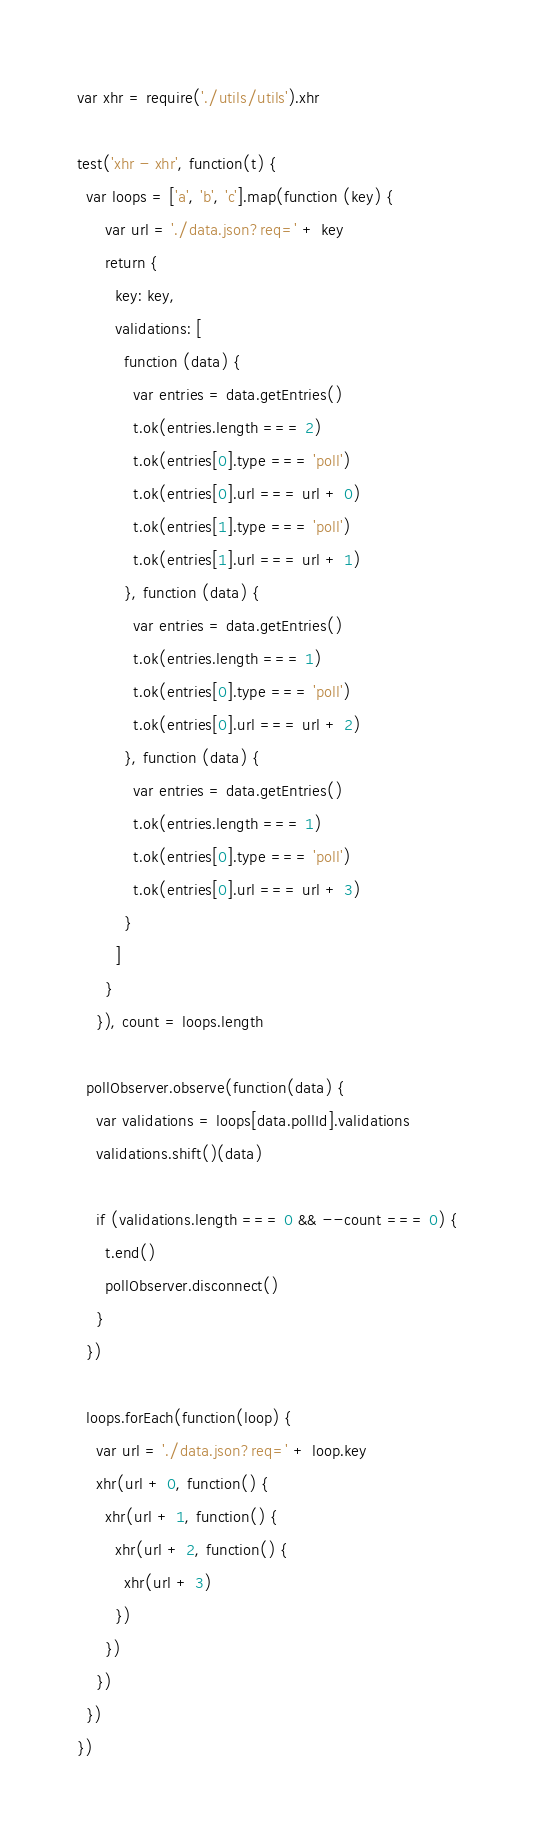Convert code to text. <code><loc_0><loc_0><loc_500><loc_500><_JavaScript_>var xhr = require('./utils/utils').xhr

test('xhr - xhr', function(t) {
  var loops = ['a', 'b', 'c'].map(function (key) {
      var url = './data.json?req=' + key
      return {
        key: key,
        validations: [
          function (data) {
            var entries = data.getEntries()
            t.ok(entries.length === 2)
            t.ok(entries[0].type === 'poll')
            t.ok(entries[0].url === url + 0)
            t.ok(entries[1].type === 'poll')
            t.ok(entries[1].url === url + 1)
          }, function (data) {
            var entries = data.getEntries()
            t.ok(entries.length === 1)
            t.ok(entries[0].type === 'poll')
            t.ok(entries[0].url === url + 2)
          }, function (data) {
            var entries = data.getEntries()
            t.ok(entries.length === 1)
            t.ok(entries[0].type === 'poll')
            t.ok(entries[0].url === url + 3)
          }
        ]
      }
    }), count = loops.length

  pollObserver.observe(function(data) {
    var validations = loops[data.pollId].validations
    validations.shift()(data)

    if (validations.length === 0 && --count === 0) {
      t.end()
      pollObserver.disconnect()
    }
  })

  loops.forEach(function(loop) {
    var url = './data.json?req=' + loop.key
    xhr(url + 0, function() {
      xhr(url + 1, function() {
        xhr(url + 2, function() {
          xhr(url + 3)
        })
      })
    })
  })
})
</code> 